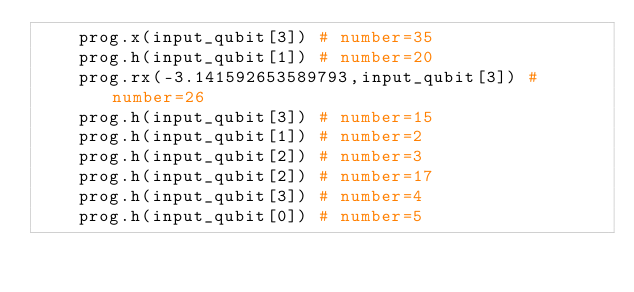<code> <loc_0><loc_0><loc_500><loc_500><_Python_>    prog.x(input_qubit[3]) # number=35
    prog.h(input_qubit[1]) # number=20
    prog.rx(-3.141592653589793,input_qubit[3]) # number=26
    prog.h(input_qubit[3]) # number=15
    prog.h(input_qubit[1]) # number=2
    prog.h(input_qubit[2]) # number=3
    prog.h(input_qubit[2]) # number=17
    prog.h(input_qubit[3]) # number=4
    prog.h(input_qubit[0]) # number=5
</code> 